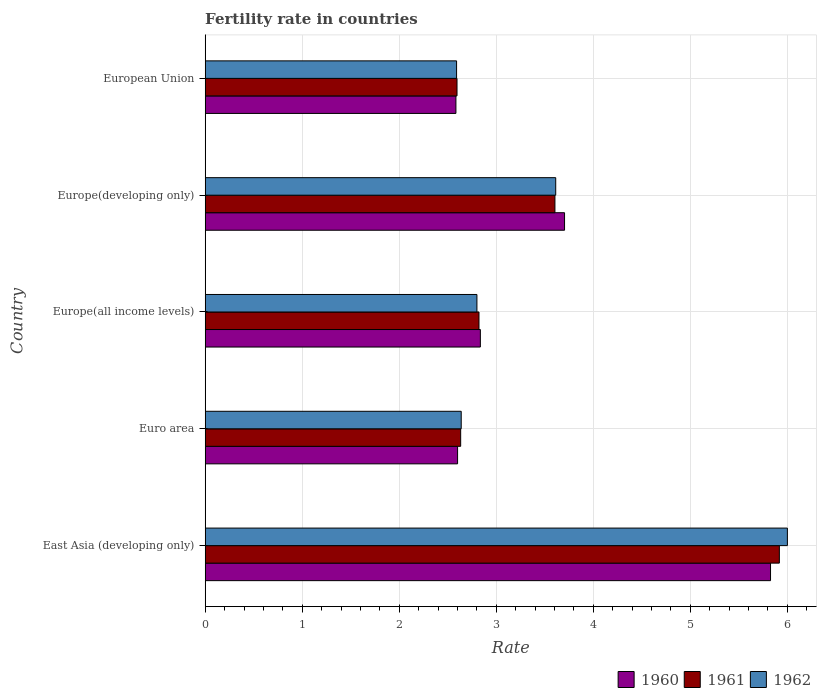How many bars are there on the 2nd tick from the top?
Provide a short and direct response. 3. What is the label of the 3rd group of bars from the top?
Ensure brevity in your answer.  Europe(all income levels). In how many cases, is the number of bars for a given country not equal to the number of legend labels?
Offer a very short reply. 0. What is the fertility rate in 1961 in Europe(all income levels)?
Your answer should be compact. 2.82. Across all countries, what is the maximum fertility rate in 1960?
Provide a short and direct response. 5.83. Across all countries, what is the minimum fertility rate in 1961?
Keep it short and to the point. 2.6. In which country was the fertility rate in 1961 maximum?
Keep it short and to the point. East Asia (developing only). What is the total fertility rate in 1960 in the graph?
Give a very brief answer. 17.55. What is the difference between the fertility rate in 1961 in Europe(all income levels) and that in Europe(developing only)?
Provide a succinct answer. -0.78. What is the difference between the fertility rate in 1960 in Euro area and the fertility rate in 1962 in Europe(all income levels)?
Your answer should be compact. -0.2. What is the average fertility rate in 1960 per country?
Your answer should be very brief. 3.51. What is the difference between the fertility rate in 1962 and fertility rate in 1961 in Euro area?
Your response must be concise. 0.01. What is the ratio of the fertility rate in 1962 in Europe(developing only) to that in European Union?
Your response must be concise. 1.39. Is the fertility rate in 1961 in East Asia (developing only) less than that in Euro area?
Provide a succinct answer. No. Is the difference between the fertility rate in 1962 in East Asia (developing only) and European Union greater than the difference between the fertility rate in 1961 in East Asia (developing only) and European Union?
Give a very brief answer. Yes. What is the difference between the highest and the second highest fertility rate in 1962?
Provide a succinct answer. 2.39. What is the difference between the highest and the lowest fertility rate in 1961?
Offer a very short reply. 3.32. In how many countries, is the fertility rate in 1962 greater than the average fertility rate in 1962 taken over all countries?
Keep it short and to the point. 2. Is the sum of the fertility rate in 1962 in Euro area and European Union greater than the maximum fertility rate in 1961 across all countries?
Give a very brief answer. No. What does the 3rd bar from the top in East Asia (developing only) represents?
Keep it short and to the point. 1960. What does the 1st bar from the bottom in Europe(developing only) represents?
Give a very brief answer. 1960. Is it the case that in every country, the sum of the fertility rate in 1961 and fertility rate in 1960 is greater than the fertility rate in 1962?
Provide a succinct answer. Yes. How many bars are there?
Offer a very short reply. 15. Does the graph contain any zero values?
Make the answer very short. No. What is the title of the graph?
Ensure brevity in your answer.  Fertility rate in countries. What is the label or title of the X-axis?
Provide a short and direct response. Rate. What is the label or title of the Y-axis?
Make the answer very short. Country. What is the Rate in 1960 in East Asia (developing only)?
Ensure brevity in your answer.  5.83. What is the Rate in 1961 in East Asia (developing only)?
Offer a terse response. 5.92. What is the Rate of 1962 in East Asia (developing only)?
Keep it short and to the point. 6. What is the Rate of 1960 in Euro area?
Make the answer very short. 2.6. What is the Rate of 1961 in Euro area?
Provide a short and direct response. 2.63. What is the Rate in 1962 in Euro area?
Your response must be concise. 2.64. What is the Rate of 1960 in Europe(all income levels)?
Offer a terse response. 2.84. What is the Rate of 1961 in Europe(all income levels)?
Offer a terse response. 2.82. What is the Rate of 1962 in Europe(all income levels)?
Provide a succinct answer. 2.8. What is the Rate of 1960 in Europe(developing only)?
Offer a very short reply. 3.7. What is the Rate of 1961 in Europe(developing only)?
Your answer should be very brief. 3.6. What is the Rate in 1962 in Europe(developing only)?
Provide a succinct answer. 3.61. What is the Rate in 1960 in European Union?
Make the answer very short. 2.58. What is the Rate in 1961 in European Union?
Provide a succinct answer. 2.6. What is the Rate in 1962 in European Union?
Your answer should be very brief. 2.59. Across all countries, what is the maximum Rate in 1960?
Offer a terse response. 5.83. Across all countries, what is the maximum Rate in 1961?
Ensure brevity in your answer.  5.92. Across all countries, what is the maximum Rate of 1962?
Ensure brevity in your answer.  6. Across all countries, what is the minimum Rate of 1960?
Your answer should be compact. 2.58. Across all countries, what is the minimum Rate in 1961?
Offer a very short reply. 2.6. Across all countries, what is the minimum Rate of 1962?
Give a very brief answer. 2.59. What is the total Rate in 1960 in the graph?
Give a very brief answer. 17.55. What is the total Rate in 1961 in the graph?
Make the answer very short. 17.57. What is the total Rate in 1962 in the graph?
Make the answer very short. 17.64. What is the difference between the Rate in 1960 in East Asia (developing only) and that in Euro area?
Ensure brevity in your answer.  3.23. What is the difference between the Rate in 1961 in East Asia (developing only) and that in Euro area?
Offer a very short reply. 3.28. What is the difference between the Rate of 1962 in East Asia (developing only) and that in Euro area?
Make the answer very short. 3.36. What is the difference between the Rate of 1960 in East Asia (developing only) and that in Europe(all income levels)?
Offer a terse response. 2.99. What is the difference between the Rate in 1961 in East Asia (developing only) and that in Europe(all income levels)?
Give a very brief answer. 3.1. What is the difference between the Rate of 1962 in East Asia (developing only) and that in Europe(all income levels)?
Your answer should be very brief. 3.2. What is the difference between the Rate in 1960 in East Asia (developing only) and that in Europe(developing only)?
Offer a terse response. 2.12. What is the difference between the Rate in 1961 in East Asia (developing only) and that in Europe(developing only)?
Offer a terse response. 2.31. What is the difference between the Rate in 1962 in East Asia (developing only) and that in Europe(developing only)?
Provide a short and direct response. 2.39. What is the difference between the Rate of 1960 in East Asia (developing only) and that in European Union?
Your answer should be compact. 3.24. What is the difference between the Rate in 1961 in East Asia (developing only) and that in European Union?
Ensure brevity in your answer.  3.32. What is the difference between the Rate of 1962 in East Asia (developing only) and that in European Union?
Your answer should be compact. 3.41. What is the difference between the Rate in 1960 in Euro area and that in Europe(all income levels)?
Make the answer very short. -0.23. What is the difference between the Rate of 1961 in Euro area and that in Europe(all income levels)?
Give a very brief answer. -0.19. What is the difference between the Rate of 1962 in Euro area and that in Europe(all income levels)?
Ensure brevity in your answer.  -0.16. What is the difference between the Rate of 1960 in Euro area and that in Europe(developing only)?
Keep it short and to the point. -1.1. What is the difference between the Rate in 1961 in Euro area and that in Europe(developing only)?
Offer a very short reply. -0.97. What is the difference between the Rate in 1962 in Euro area and that in Europe(developing only)?
Your answer should be very brief. -0.97. What is the difference between the Rate in 1960 in Euro area and that in European Union?
Ensure brevity in your answer.  0.02. What is the difference between the Rate in 1961 in Euro area and that in European Union?
Provide a short and direct response. 0.04. What is the difference between the Rate in 1962 in Euro area and that in European Union?
Your response must be concise. 0.05. What is the difference between the Rate of 1960 in Europe(all income levels) and that in Europe(developing only)?
Your response must be concise. -0.87. What is the difference between the Rate of 1961 in Europe(all income levels) and that in Europe(developing only)?
Keep it short and to the point. -0.78. What is the difference between the Rate in 1962 in Europe(all income levels) and that in Europe(developing only)?
Your answer should be very brief. -0.81. What is the difference between the Rate in 1960 in Europe(all income levels) and that in European Union?
Your answer should be very brief. 0.25. What is the difference between the Rate in 1961 in Europe(all income levels) and that in European Union?
Offer a terse response. 0.23. What is the difference between the Rate of 1962 in Europe(all income levels) and that in European Union?
Your answer should be compact. 0.21. What is the difference between the Rate in 1960 in Europe(developing only) and that in European Union?
Your response must be concise. 1.12. What is the difference between the Rate of 1961 in Europe(developing only) and that in European Union?
Keep it short and to the point. 1.01. What is the difference between the Rate of 1962 in Europe(developing only) and that in European Union?
Your answer should be compact. 1.02. What is the difference between the Rate in 1960 in East Asia (developing only) and the Rate in 1961 in Euro area?
Give a very brief answer. 3.19. What is the difference between the Rate in 1960 in East Asia (developing only) and the Rate in 1962 in Euro area?
Keep it short and to the point. 3.19. What is the difference between the Rate in 1961 in East Asia (developing only) and the Rate in 1962 in Euro area?
Your answer should be compact. 3.28. What is the difference between the Rate of 1960 in East Asia (developing only) and the Rate of 1961 in Europe(all income levels)?
Provide a short and direct response. 3. What is the difference between the Rate in 1960 in East Asia (developing only) and the Rate in 1962 in Europe(all income levels)?
Provide a succinct answer. 3.03. What is the difference between the Rate in 1961 in East Asia (developing only) and the Rate in 1962 in Europe(all income levels)?
Provide a succinct answer. 3.12. What is the difference between the Rate of 1960 in East Asia (developing only) and the Rate of 1961 in Europe(developing only)?
Give a very brief answer. 2.22. What is the difference between the Rate of 1960 in East Asia (developing only) and the Rate of 1962 in Europe(developing only)?
Your answer should be compact. 2.21. What is the difference between the Rate of 1961 in East Asia (developing only) and the Rate of 1962 in Europe(developing only)?
Keep it short and to the point. 2.31. What is the difference between the Rate in 1960 in East Asia (developing only) and the Rate in 1961 in European Union?
Your answer should be compact. 3.23. What is the difference between the Rate of 1960 in East Asia (developing only) and the Rate of 1962 in European Union?
Make the answer very short. 3.24. What is the difference between the Rate of 1961 in East Asia (developing only) and the Rate of 1962 in European Union?
Keep it short and to the point. 3.33. What is the difference between the Rate of 1960 in Euro area and the Rate of 1961 in Europe(all income levels)?
Make the answer very short. -0.22. What is the difference between the Rate in 1960 in Euro area and the Rate in 1962 in Europe(all income levels)?
Ensure brevity in your answer.  -0.2. What is the difference between the Rate in 1961 in Euro area and the Rate in 1962 in Europe(all income levels)?
Give a very brief answer. -0.17. What is the difference between the Rate in 1960 in Euro area and the Rate in 1961 in Europe(developing only)?
Provide a short and direct response. -1. What is the difference between the Rate of 1960 in Euro area and the Rate of 1962 in Europe(developing only)?
Offer a very short reply. -1.01. What is the difference between the Rate in 1961 in Euro area and the Rate in 1962 in Europe(developing only)?
Keep it short and to the point. -0.98. What is the difference between the Rate in 1960 in Euro area and the Rate in 1961 in European Union?
Keep it short and to the point. 0.01. What is the difference between the Rate of 1960 in Euro area and the Rate of 1962 in European Union?
Offer a very short reply. 0.01. What is the difference between the Rate of 1961 in Euro area and the Rate of 1962 in European Union?
Provide a short and direct response. 0.04. What is the difference between the Rate in 1960 in Europe(all income levels) and the Rate in 1961 in Europe(developing only)?
Provide a succinct answer. -0.77. What is the difference between the Rate of 1960 in Europe(all income levels) and the Rate of 1962 in Europe(developing only)?
Ensure brevity in your answer.  -0.78. What is the difference between the Rate in 1961 in Europe(all income levels) and the Rate in 1962 in Europe(developing only)?
Provide a short and direct response. -0.79. What is the difference between the Rate in 1960 in Europe(all income levels) and the Rate in 1961 in European Union?
Provide a succinct answer. 0.24. What is the difference between the Rate of 1960 in Europe(all income levels) and the Rate of 1962 in European Union?
Keep it short and to the point. 0.25. What is the difference between the Rate of 1961 in Europe(all income levels) and the Rate of 1962 in European Union?
Your answer should be compact. 0.23. What is the difference between the Rate of 1960 in Europe(developing only) and the Rate of 1961 in European Union?
Provide a succinct answer. 1.11. What is the difference between the Rate of 1960 in Europe(developing only) and the Rate of 1962 in European Union?
Ensure brevity in your answer.  1.11. What is the difference between the Rate in 1961 in Europe(developing only) and the Rate in 1962 in European Union?
Give a very brief answer. 1.01. What is the average Rate of 1960 per country?
Make the answer very short. 3.51. What is the average Rate in 1961 per country?
Make the answer very short. 3.51. What is the average Rate of 1962 per country?
Make the answer very short. 3.53. What is the difference between the Rate of 1960 and Rate of 1961 in East Asia (developing only)?
Offer a very short reply. -0.09. What is the difference between the Rate in 1960 and Rate in 1962 in East Asia (developing only)?
Offer a terse response. -0.17. What is the difference between the Rate in 1961 and Rate in 1962 in East Asia (developing only)?
Ensure brevity in your answer.  -0.08. What is the difference between the Rate in 1960 and Rate in 1961 in Euro area?
Ensure brevity in your answer.  -0.03. What is the difference between the Rate in 1960 and Rate in 1962 in Euro area?
Your response must be concise. -0.04. What is the difference between the Rate in 1961 and Rate in 1962 in Euro area?
Give a very brief answer. -0.01. What is the difference between the Rate in 1960 and Rate in 1961 in Europe(all income levels)?
Keep it short and to the point. 0.01. What is the difference between the Rate of 1960 and Rate of 1962 in Europe(all income levels)?
Provide a succinct answer. 0.04. What is the difference between the Rate in 1961 and Rate in 1962 in Europe(all income levels)?
Your answer should be compact. 0.02. What is the difference between the Rate of 1960 and Rate of 1961 in Europe(developing only)?
Ensure brevity in your answer.  0.1. What is the difference between the Rate in 1960 and Rate in 1962 in Europe(developing only)?
Provide a succinct answer. 0.09. What is the difference between the Rate of 1961 and Rate of 1962 in Europe(developing only)?
Offer a very short reply. -0.01. What is the difference between the Rate in 1960 and Rate in 1961 in European Union?
Offer a terse response. -0.01. What is the difference between the Rate in 1960 and Rate in 1962 in European Union?
Ensure brevity in your answer.  -0.01. What is the difference between the Rate in 1961 and Rate in 1962 in European Union?
Provide a short and direct response. 0. What is the ratio of the Rate of 1960 in East Asia (developing only) to that in Euro area?
Your answer should be very brief. 2.24. What is the ratio of the Rate of 1961 in East Asia (developing only) to that in Euro area?
Your answer should be compact. 2.25. What is the ratio of the Rate of 1962 in East Asia (developing only) to that in Euro area?
Keep it short and to the point. 2.27. What is the ratio of the Rate of 1960 in East Asia (developing only) to that in Europe(all income levels)?
Your answer should be compact. 2.05. What is the ratio of the Rate of 1961 in East Asia (developing only) to that in Europe(all income levels)?
Keep it short and to the point. 2.1. What is the ratio of the Rate of 1962 in East Asia (developing only) to that in Europe(all income levels)?
Make the answer very short. 2.14. What is the ratio of the Rate of 1960 in East Asia (developing only) to that in Europe(developing only)?
Provide a succinct answer. 1.57. What is the ratio of the Rate of 1961 in East Asia (developing only) to that in Europe(developing only)?
Offer a very short reply. 1.64. What is the ratio of the Rate in 1962 in East Asia (developing only) to that in Europe(developing only)?
Ensure brevity in your answer.  1.66. What is the ratio of the Rate in 1960 in East Asia (developing only) to that in European Union?
Keep it short and to the point. 2.25. What is the ratio of the Rate of 1961 in East Asia (developing only) to that in European Union?
Offer a terse response. 2.28. What is the ratio of the Rate of 1962 in East Asia (developing only) to that in European Union?
Your response must be concise. 2.32. What is the ratio of the Rate in 1960 in Euro area to that in Europe(all income levels)?
Ensure brevity in your answer.  0.92. What is the ratio of the Rate in 1961 in Euro area to that in Europe(all income levels)?
Keep it short and to the point. 0.93. What is the ratio of the Rate in 1962 in Euro area to that in Europe(all income levels)?
Make the answer very short. 0.94. What is the ratio of the Rate of 1960 in Euro area to that in Europe(developing only)?
Your response must be concise. 0.7. What is the ratio of the Rate of 1961 in Euro area to that in Europe(developing only)?
Offer a very short reply. 0.73. What is the ratio of the Rate in 1962 in Euro area to that in Europe(developing only)?
Provide a succinct answer. 0.73. What is the ratio of the Rate of 1960 in Euro area to that in European Union?
Keep it short and to the point. 1.01. What is the ratio of the Rate in 1961 in Euro area to that in European Union?
Give a very brief answer. 1.01. What is the ratio of the Rate of 1962 in Euro area to that in European Union?
Make the answer very short. 1.02. What is the ratio of the Rate in 1960 in Europe(all income levels) to that in Europe(developing only)?
Provide a short and direct response. 0.77. What is the ratio of the Rate in 1961 in Europe(all income levels) to that in Europe(developing only)?
Offer a very short reply. 0.78. What is the ratio of the Rate of 1962 in Europe(all income levels) to that in Europe(developing only)?
Keep it short and to the point. 0.78. What is the ratio of the Rate in 1960 in Europe(all income levels) to that in European Union?
Your response must be concise. 1.1. What is the ratio of the Rate of 1961 in Europe(all income levels) to that in European Union?
Provide a short and direct response. 1.09. What is the ratio of the Rate of 1962 in Europe(all income levels) to that in European Union?
Ensure brevity in your answer.  1.08. What is the ratio of the Rate of 1960 in Europe(developing only) to that in European Union?
Give a very brief answer. 1.43. What is the ratio of the Rate of 1961 in Europe(developing only) to that in European Union?
Offer a terse response. 1.39. What is the ratio of the Rate of 1962 in Europe(developing only) to that in European Union?
Your answer should be very brief. 1.39. What is the difference between the highest and the second highest Rate of 1960?
Keep it short and to the point. 2.12. What is the difference between the highest and the second highest Rate in 1961?
Make the answer very short. 2.31. What is the difference between the highest and the second highest Rate of 1962?
Your answer should be compact. 2.39. What is the difference between the highest and the lowest Rate of 1960?
Offer a terse response. 3.24. What is the difference between the highest and the lowest Rate in 1961?
Give a very brief answer. 3.32. What is the difference between the highest and the lowest Rate in 1962?
Provide a succinct answer. 3.41. 